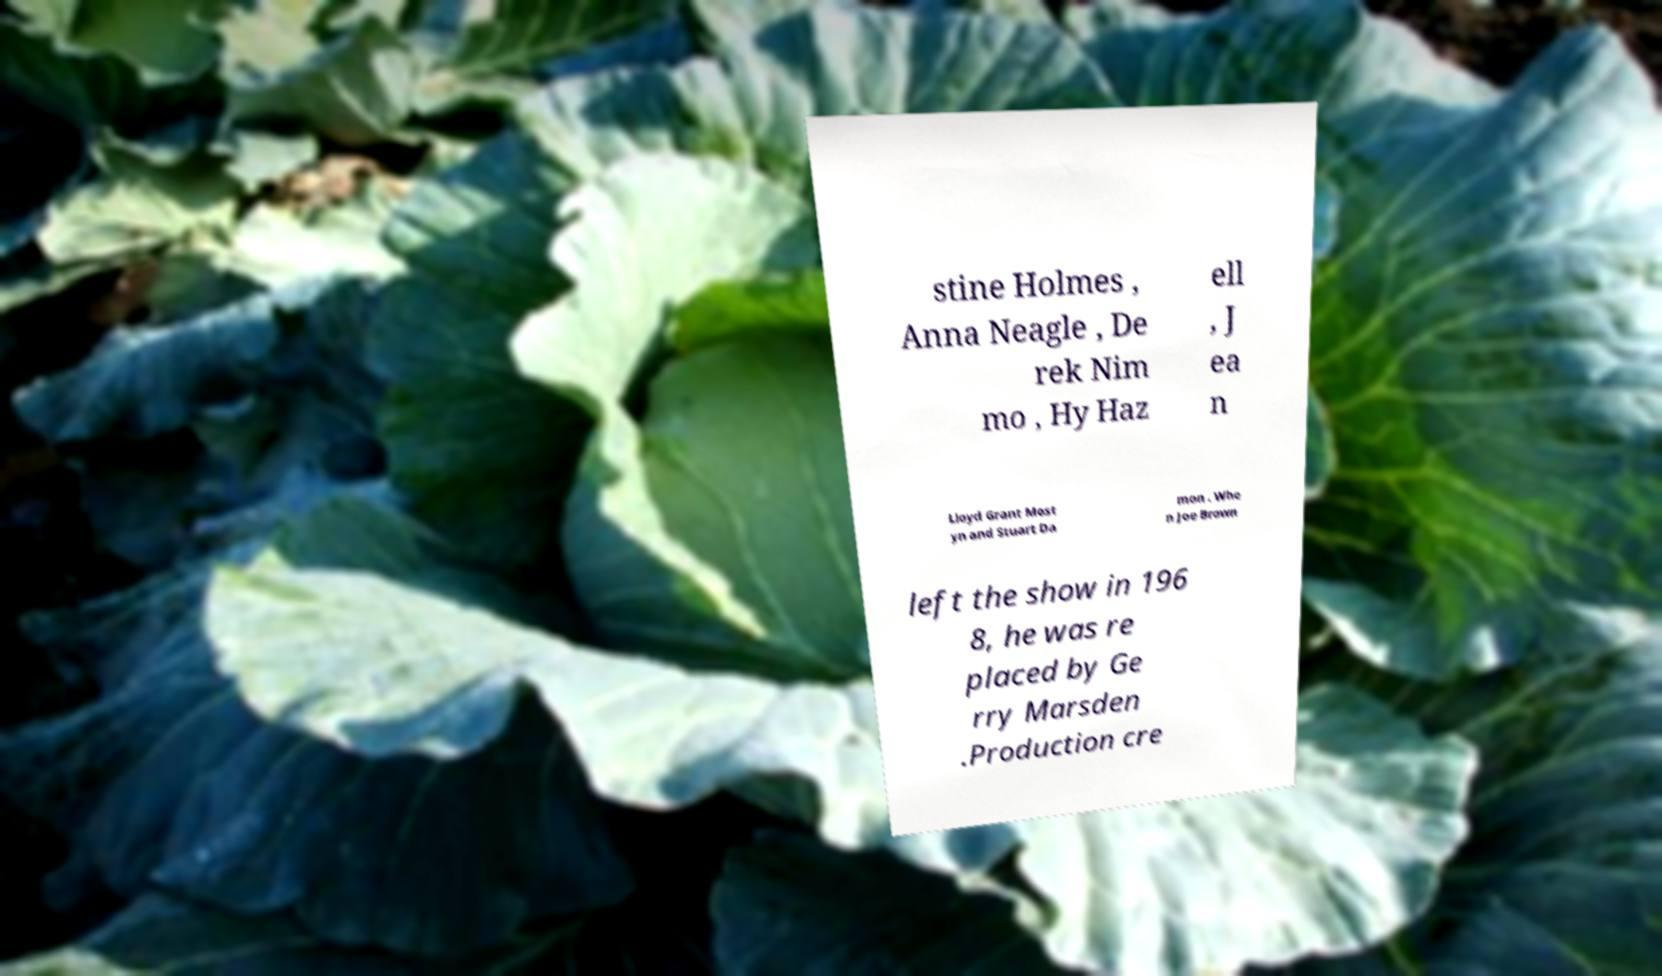Please read and relay the text visible in this image. What does it say? stine Holmes , Anna Neagle , De rek Nim mo , Hy Haz ell , J ea n Lloyd Grant Most yn and Stuart Da mon . Whe n Joe Brown left the show in 196 8, he was re placed by Ge rry Marsden .Production cre 